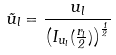Convert formula to latex. <formula><loc_0><loc_0><loc_500><loc_500>\tilde { u } _ { l } = \frac { u _ { l } } { \left ( I _ { u _ { l } } ( \frac { r _ { l } } { 2 } ) \right ) ^ { \frac { 1 } { 2 } } }</formula> 